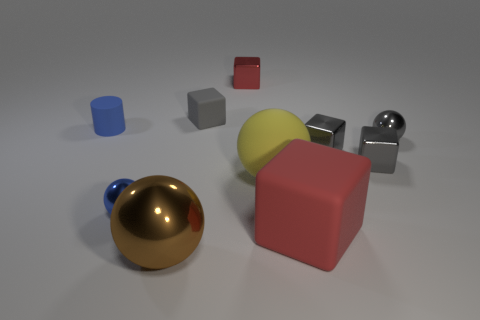Do the gray sphere and the sphere that is to the left of the brown object have the same material? yes 